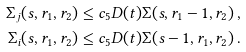Convert formula to latex. <formula><loc_0><loc_0><loc_500><loc_500>\Sigma _ { j } ( s , r _ { 1 } , r _ { 2 } ) \leq c _ { 5 } D ( t ) \Sigma ( s , r _ { 1 } - 1 , r _ { 2 } ) \, , \\ \Sigma _ { i } ( s , r _ { 1 } , r _ { 2 } ) \leq c _ { 5 } D ( t ) \Sigma ( s - 1 , r _ { 1 } , r _ { 2 } ) \, .</formula> 